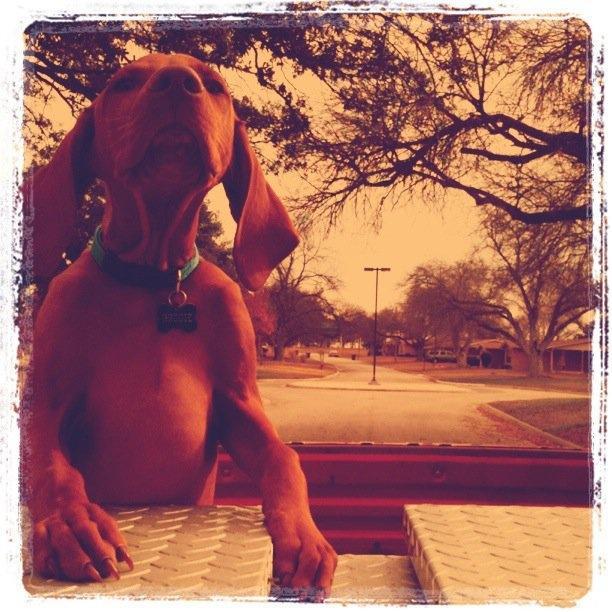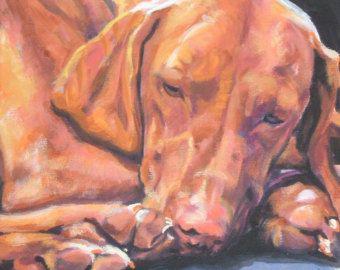The first image is the image on the left, the second image is the image on the right. Given the left and right images, does the statement "In one image, a dog's upright head and shoulders are behind a squarish flat surface which its front paws are over." hold true? Answer yes or no. Yes. 